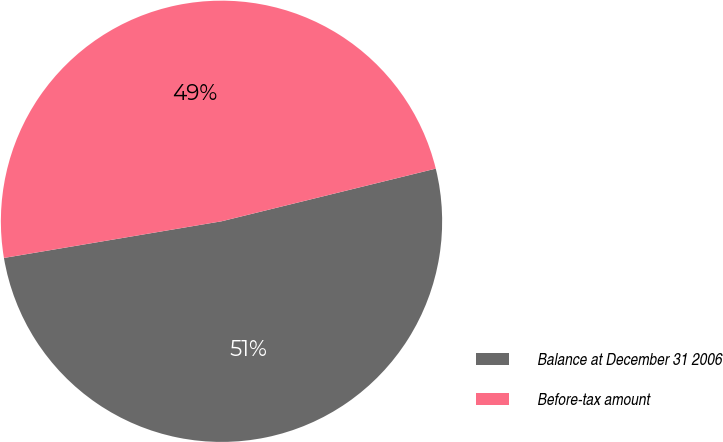<chart> <loc_0><loc_0><loc_500><loc_500><pie_chart><fcel>Balance at December 31 2006<fcel>Before-tax amount<nl><fcel>51.18%<fcel>48.82%<nl></chart> 